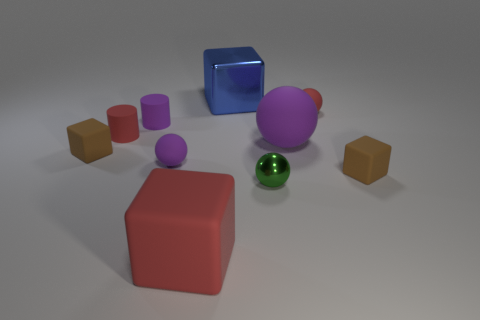Subtract all blocks. How many objects are left? 6 Add 4 small brown blocks. How many small brown blocks are left? 6 Add 3 big red things. How many big red things exist? 4 Subtract 0 gray spheres. How many objects are left? 10 Subtract all tiny purple rubber objects. Subtract all red blocks. How many objects are left? 7 